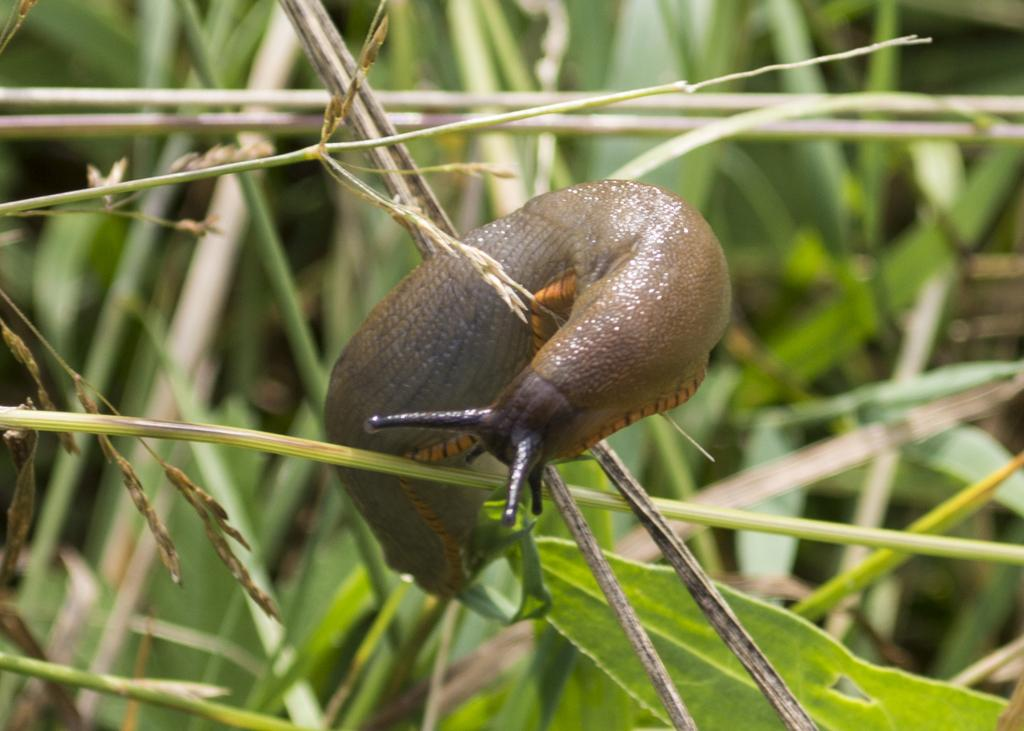What type of animal is in the picture? There is a snail in the picture. What color is the grass in the picture? There is green grass in the picture. What can be seen at the bottom of the picture? There are green leaves at the bottom of the picture. What type of toys can be seen in the picture? There are no toys present in the picture; it features a snail, green grass, and green leaves. Does the snail have a tail in the picture? Snails do not have tails, so there is no tail visible in the picture. 